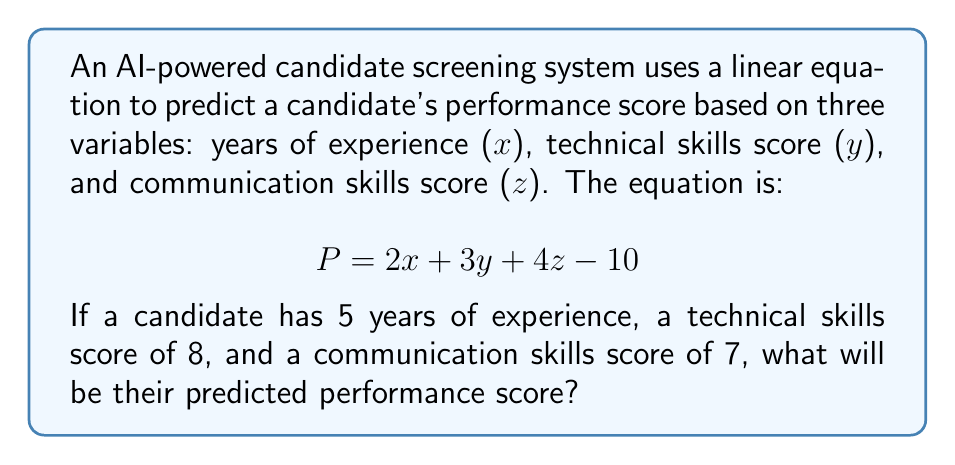Help me with this question. To solve this problem, we need to substitute the given values into the linear equation:

1. We are given:
   $x = 5$ (years of experience)
   $y = 8$ (technical skills score)
   $z = 7$ (communication skills score)

2. The linear equation is:
   $$P = 2x + 3y + 4z - 10$$

3. Substitute the values:
   $$P = 2(5) + 3(8) + 4(7) - 10$$

4. Simplify:
   $$P = 10 + 24 + 28 - 10$$

5. Calculate the final result:
   $$P = 62 - 10 = 52$$

Therefore, the predicted performance score for this candidate is 52.
Answer: 52 